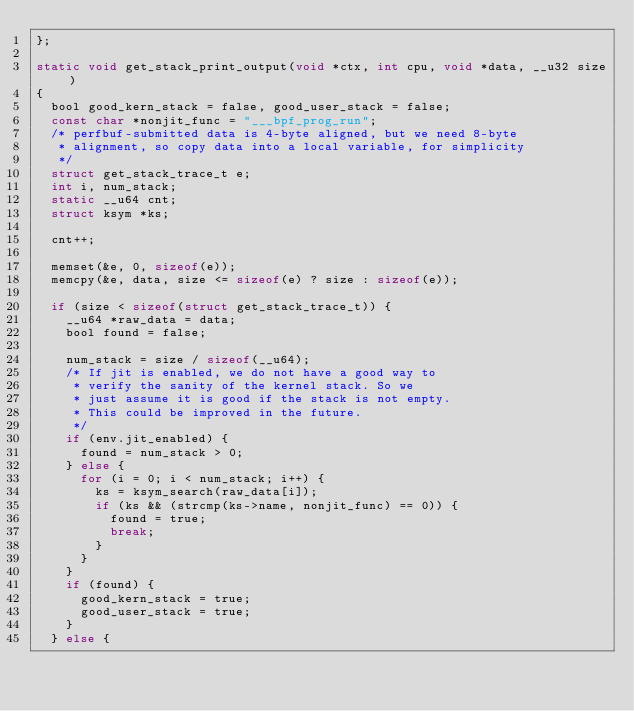<code> <loc_0><loc_0><loc_500><loc_500><_C_>};

static void get_stack_print_output(void *ctx, int cpu, void *data, __u32 size)
{
	bool good_kern_stack = false, good_user_stack = false;
	const char *nonjit_func = "___bpf_prog_run";
	/* perfbuf-submitted data is 4-byte aligned, but we need 8-byte
	 * alignment, so copy data into a local variable, for simplicity
	 */
	struct get_stack_trace_t e;
	int i, num_stack;
	static __u64 cnt;
	struct ksym *ks;

	cnt++;

	memset(&e, 0, sizeof(e));
	memcpy(&e, data, size <= sizeof(e) ? size : sizeof(e));

	if (size < sizeof(struct get_stack_trace_t)) {
		__u64 *raw_data = data;
		bool found = false;

		num_stack = size / sizeof(__u64);
		/* If jit is enabled, we do not have a good way to
		 * verify the sanity of the kernel stack. So we
		 * just assume it is good if the stack is not empty.
		 * This could be improved in the future.
		 */
		if (env.jit_enabled) {
			found = num_stack > 0;
		} else {
			for (i = 0; i < num_stack; i++) {
				ks = ksym_search(raw_data[i]);
				if (ks && (strcmp(ks->name, nonjit_func) == 0)) {
					found = true;
					break;
				}
			}
		}
		if (found) {
			good_kern_stack = true;
			good_user_stack = true;
		}
	} else {</code> 